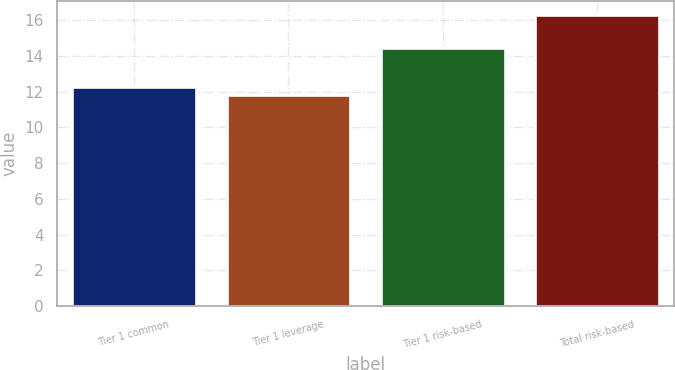Convert chart to OTSL. <chart><loc_0><loc_0><loc_500><loc_500><bar_chart><fcel>Tier 1 common<fcel>Tier 1 leverage<fcel>Tier 1 risk-based<fcel>Total risk-based<nl><fcel>12.27<fcel>11.82<fcel>14.47<fcel>16.27<nl></chart> 